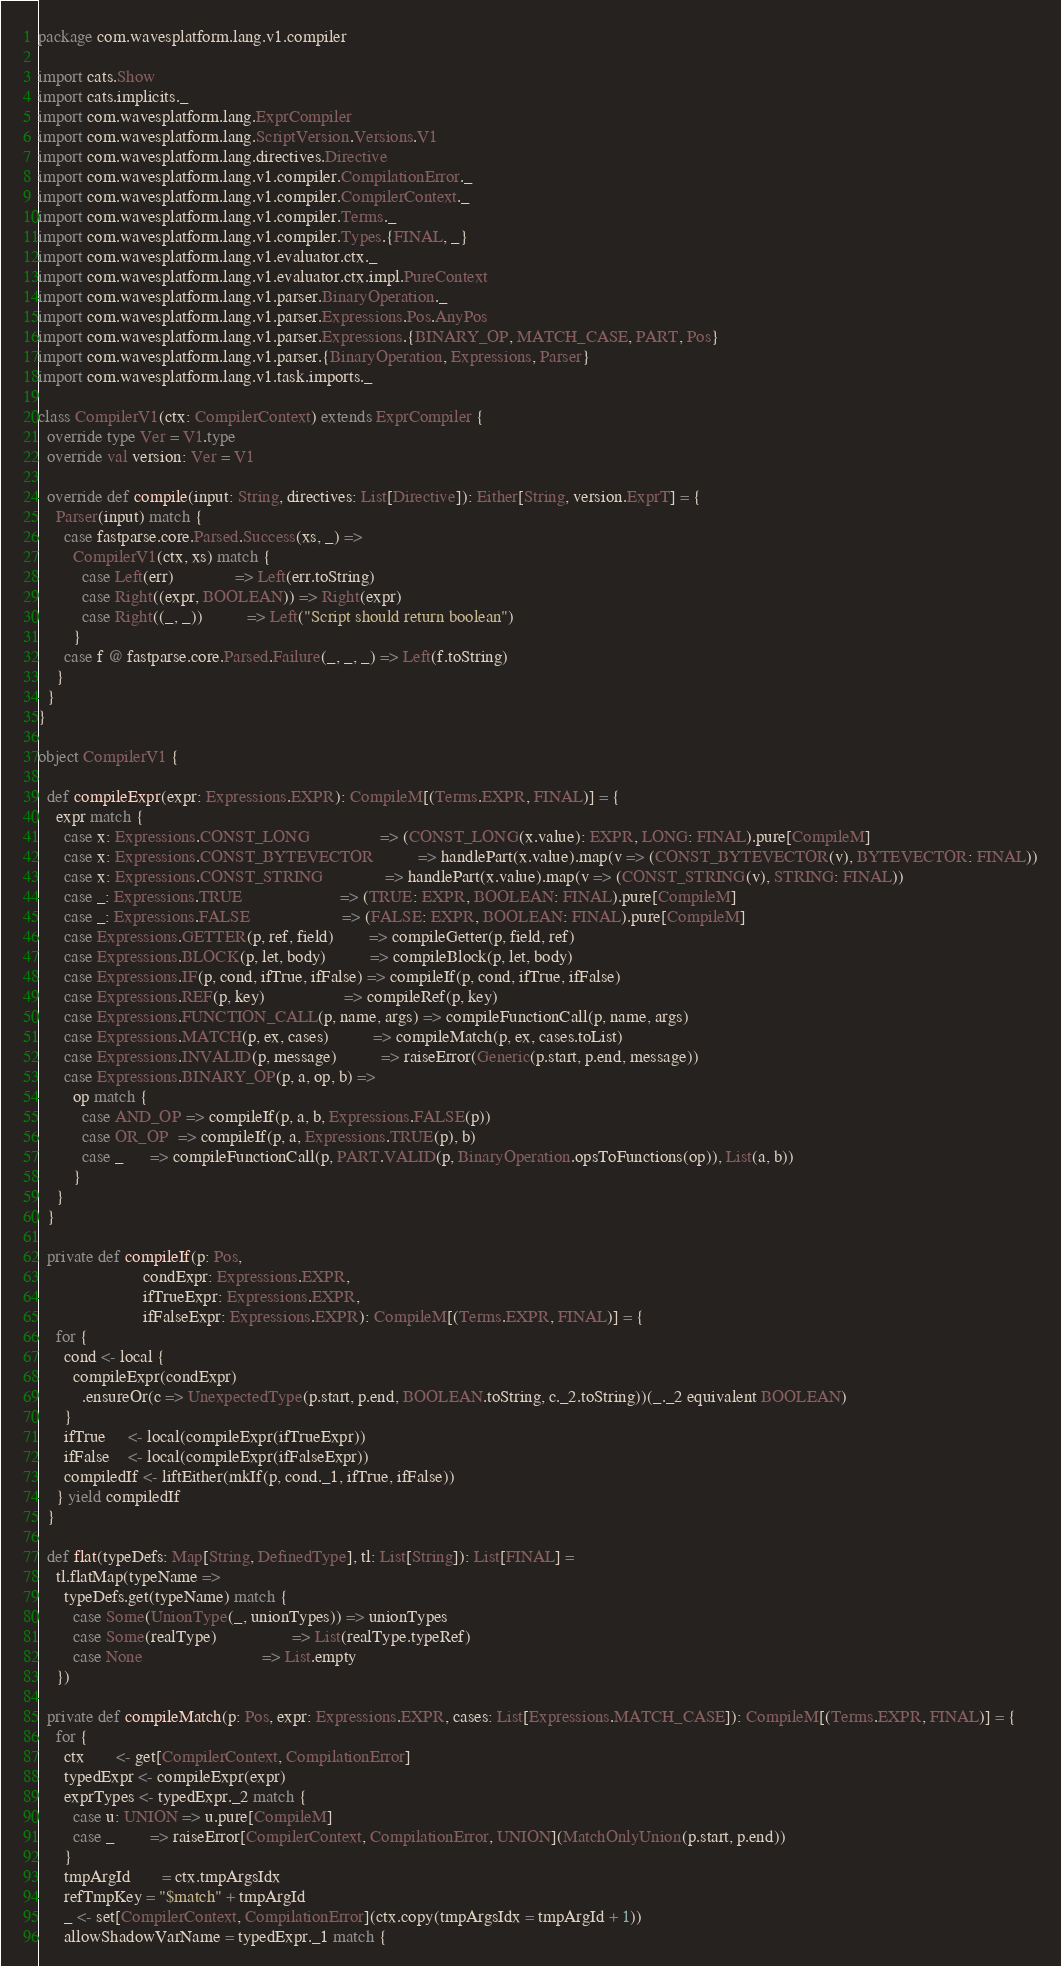<code> <loc_0><loc_0><loc_500><loc_500><_Scala_>package com.wavesplatform.lang.v1.compiler

import cats.Show
import cats.implicits._
import com.wavesplatform.lang.ExprCompiler
import com.wavesplatform.lang.ScriptVersion.Versions.V1
import com.wavesplatform.lang.directives.Directive
import com.wavesplatform.lang.v1.compiler.CompilationError._
import com.wavesplatform.lang.v1.compiler.CompilerContext._
import com.wavesplatform.lang.v1.compiler.Terms._
import com.wavesplatform.lang.v1.compiler.Types.{FINAL, _}
import com.wavesplatform.lang.v1.evaluator.ctx._
import com.wavesplatform.lang.v1.evaluator.ctx.impl.PureContext
import com.wavesplatform.lang.v1.parser.BinaryOperation._
import com.wavesplatform.lang.v1.parser.Expressions.Pos.AnyPos
import com.wavesplatform.lang.v1.parser.Expressions.{BINARY_OP, MATCH_CASE, PART, Pos}
import com.wavesplatform.lang.v1.parser.{BinaryOperation, Expressions, Parser}
import com.wavesplatform.lang.v1.task.imports._

class CompilerV1(ctx: CompilerContext) extends ExprCompiler {
  override type Ver = V1.type
  override val version: Ver = V1

  override def compile(input: String, directives: List[Directive]): Either[String, version.ExprT] = {
    Parser(input) match {
      case fastparse.core.Parsed.Success(xs, _) =>
        CompilerV1(ctx, xs) match {
          case Left(err)              => Left(err.toString)
          case Right((expr, BOOLEAN)) => Right(expr)
          case Right((_, _))          => Left("Script should return boolean")
        }
      case f @ fastparse.core.Parsed.Failure(_, _, _) => Left(f.toString)
    }
  }
}

object CompilerV1 {

  def compileExpr(expr: Expressions.EXPR): CompileM[(Terms.EXPR, FINAL)] = {
    expr match {
      case x: Expressions.CONST_LONG                => (CONST_LONG(x.value): EXPR, LONG: FINAL).pure[CompileM]
      case x: Expressions.CONST_BYTEVECTOR          => handlePart(x.value).map(v => (CONST_BYTEVECTOR(v), BYTEVECTOR: FINAL))
      case x: Expressions.CONST_STRING              => handlePart(x.value).map(v => (CONST_STRING(v), STRING: FINAL))
      case _: Expressions.TRUE                      => (TRUE: EXPR, BOOLEAN: FINAL).pure[CompileM]
      case _: Expressions.FALSE                     => (FALSE: EXPR, BOOLEAN: FINAL).pure[CompileM]
      case Expressions.GETTER(p, ref, field)        => compileGetter(p, field, ref)
      case Expressions.BLOCK(p, let, body)          => compileBlock(p, let, body)
      case Expressions.IF(p, cond, ifTrue, ifFalse) => compileIf(p, cond, ifTrue, ifFalse)
      case Expressions.REF(p, key)                  => compileRef(p, key)
      case Expressions.FUNCTION_CALL(p, name, args) => compileFunctionCall(p, name, args)
      case Expressions.MATCH(p, ex, cases)          => compileMatch(p, ex, cases.toList)
      case Expressions.INVALID(p, message)          => raiseError(Generic(p.start, p.end, message))
      case Expressions.BINARY_OP(p, a, op, b) =>
        op match {
          case AND_OP => compileIf(p, a, b, Expressions.FALSE(p))
          case OR_OP  => compileIf(p, a, Expressions.TRUE(p), b)
          case _      => compileFunctionCall(p, PART.VALID(p, BinaryOperation.opsToFunctions(op)), List(a, b))
        }
    }
  }

  private def compileIf(p: Pos,
                        condExpr: Expressions.EXPR,
                        ifTrueExpr: Expressions.EXPR,
                        ifFalseExpr: Expressions.EXPR): CompileM[(Terms.EXPR, FINAL)] = {
    for {
      cond <- local {
        compileExpr(condExpr)
          .ensureOr(c => UnexpectedType(p.start, p.end, BOOLEAN.toString, c._2.toString))(_._2 equivalent BOOLEAN)
      }
      ifTrue     <- local(compileExpr(ifTrueExpr))
      ifFalse    <- local(compileExpr(ifFalseExpr))
      compiledIf <- liftEither(mkIf(p, cond._1, ifTrue, ifFalse))
    } yield compiledIf
  }

  def flat(typeDefs: Map[String, DefinedType], tl: List[String]): List[FINAL] =
    tl.flatMap(typeName =>
      typeDefs.get(typeName) match {
        case Some(UnionType(_, unionTypes)) => unionTypes
        case Some(realType)                 => List(realType.typeRef)
        case None                           => List.empty
    })

  private def compileMatch(p: Pos, expr: Expressions.EXPR, cases: List[Expressions.MATCH_CASE]): CompileM[(Terms.EXPR, FINAL)] = {
    for {
      ctx       <- get[CompilerContext, CompilationError]
      typedExpr <- compileExpr(expr)
      exprTypes <- typedExpr._2 match {
        case u: UNION => u.pure[CompileM]
        case _        => raiseError[CompilerContext, CompilationError, UNION](MatchOnlyUnion(p.start, p.end))
      }
      tmpArgId       = ctx.tmpArgsIdx
      refTmpKey = "$match" + tmpArgId
      _ <- set[CompilerContext, CompilationError](ctx.copy(tmpArgsIdx = tmpArgId + 1))
      allowShadowVarName = typedExpr._1 match {</code> 